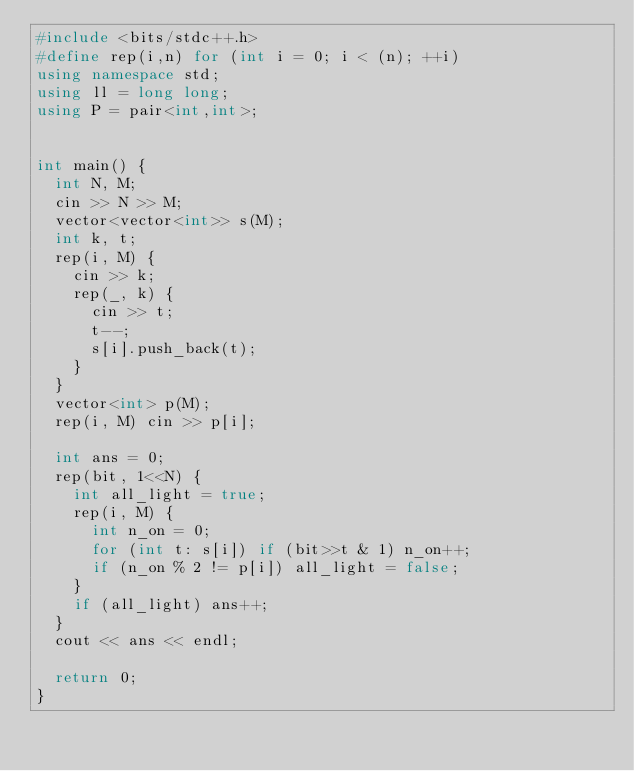Convert code to text. <code><loc_0><loc_0><loc_500><loc_500><_C++_>#include <bits/stdc++.h>
#define rep(i,n) for (int i = 0; i < (n); ++i)
using namespace std;
using ll = long long;
using P = pair<int,int>;


int main() {
  int N, M;
  cin >> N >> M;
  vector<vector<int>> s(M);
  int k, t;
  rep(i, M) {
    cin >> k;
    rep(_, k) {
      cin >> t;
      t--;
      s[i].push_back(t);
    }
  }
  vector<int> p(M);
  rep(i, M) cin >> p[i];
  
  int ans = 0;
  rep(bit, 1<<N) {
    int all_light = true;
    rep(i, M) {
      int n_on = 0;
      for (int t: s[i]) if (bit>>t & 1) n_on++;
      if (n_on % 2 != p[i]) all_light = false;
    }
    if (all_light) ans++;
  }
  cout << ans << endl;  

  return 0;
}
</code> 